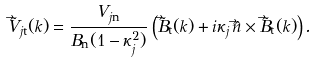Convert formula to latex. <formula><loc_0><loc_0><loc_500><loc_500>\tilde { \vec { V } } _ { j \mathrm t } ( k ) = \frac { V _ { j \mathrm n } } { B _ { \mathrm n } ( 1 - \kappa _ { j } ^ { 2 } ) } \left ( \tilde { \vec { B } } _ { \mathrm t } ( k ) + i \kappa _ { j } \, \hat { \vec { n } } \times \tilde { \vec { B } } _ { \mathrm t } ( k ) \right ) .</formula> 